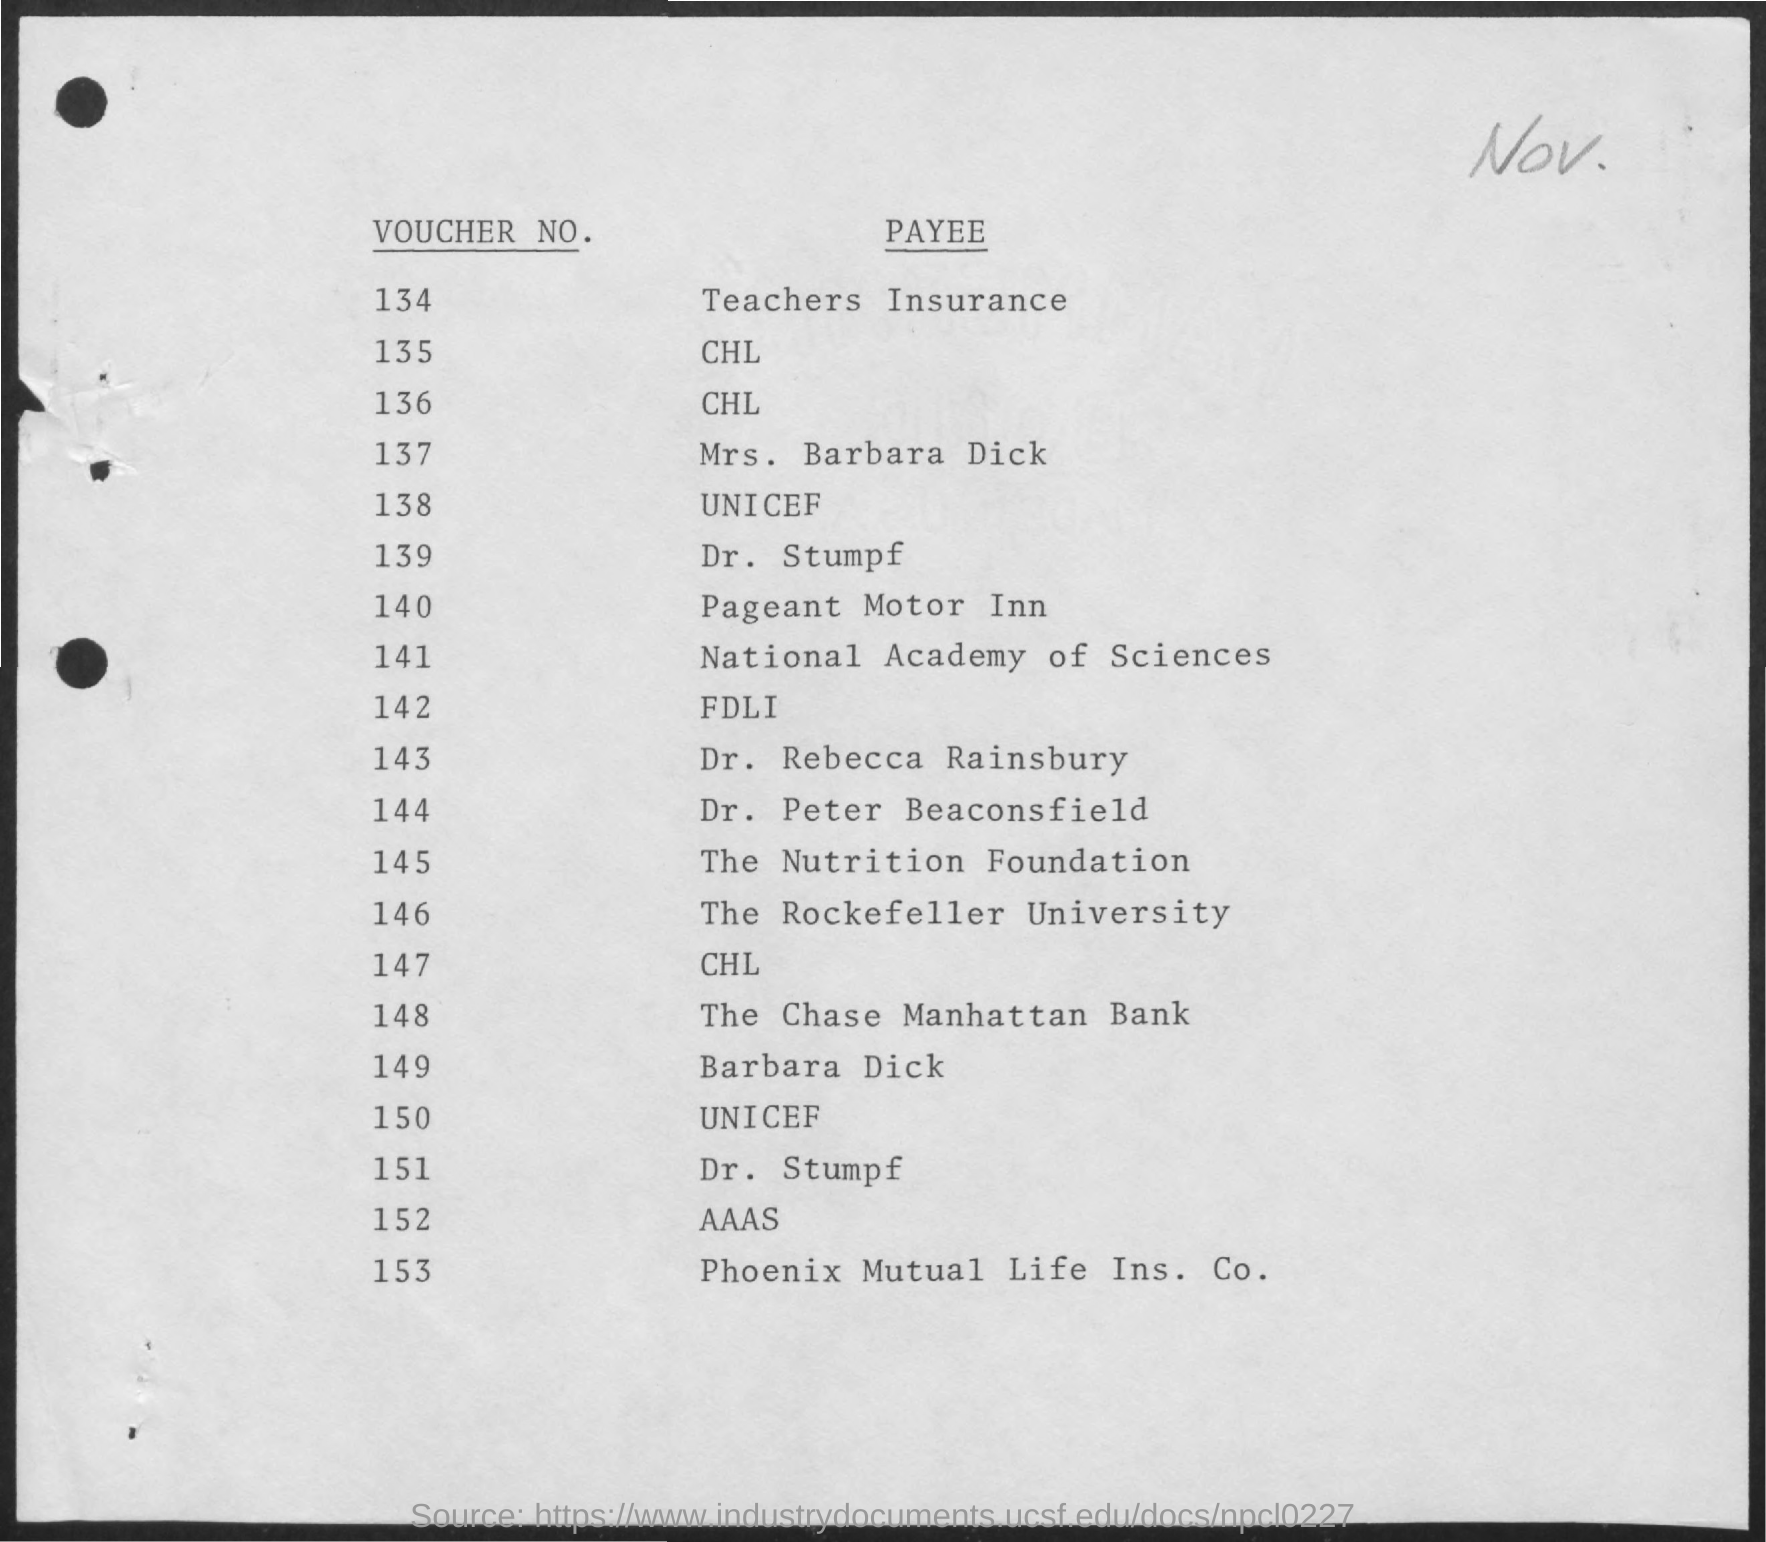What is the Voucher No. for Teachers Insurance?
Make the answer very short. 134. Who is the last Voucher payee listed?
Provide a short and direct response. Phoenix Mutual Life Ins. Co. 